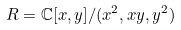Convert formula to latex. <formula><loc_0><loc_0><loc_500><loc_500>R = \mathbb { C } [ x , y ] / ( x ^ { 2 } , x y , y ^ { 2 } )</formula> 